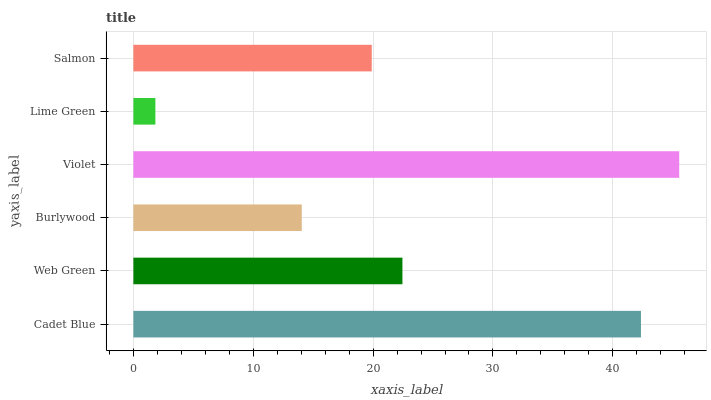Is Lime Green the minimum?
Answer yes or no. Yes. Is Violet the maximum?
Answer yes or no. Yes. Is Web Green the minimum?
Answer yes or no. No. Is Web Green the maximum?
Answer yes or no. No. Is Cadet Blue greater than Web Green?
Answer yes or no. Yes. Is Web Green less than Cadet Blue?
Answer yes or no. Yes. Is Web Green greater than Cadet Blue?
Answer yes or no. No. Is Cadet Blue less than Web Green?
Answer yes or no. No. Is Web Green the high median?
Answer yes or no. Yes. Is Salmon the low median?
Answer yes or no. Yes. Is Salmon the high median?
Answer yes or no. No. Is Burlywood the low median?
Answer yes or no. No. 